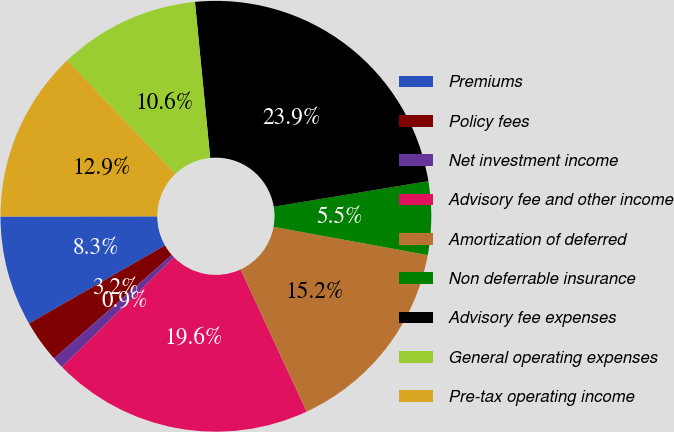Convert chart to OTSL. <chart><loc_0><loc_0><loc_500><loc_500><pie_chart><fcel>Premiums<fcel>Policy fees<fcel>Net investment income<fcel>Advisory fee and other income<fcel>Amortization of deferred<fcel>Non deferrable insurance<fcel>Advisory fee expenses<fcel>General operating expenses<fcel>Pre-tax operating income<nl><fcel>8.27%<fcel>3.18%<fcel>0.87%<fcel>19.59%<fcel>15.19%<fcel>5.49%<fcel>23.94%<fcel>10.58%<fcel>12.89%<nl></chart> 